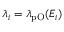<formula> <loc_0><loc_0><loc_500><loc_500>\lambda _ { i } = \lambda _ { p O } ( E _ { i } )</formula> 